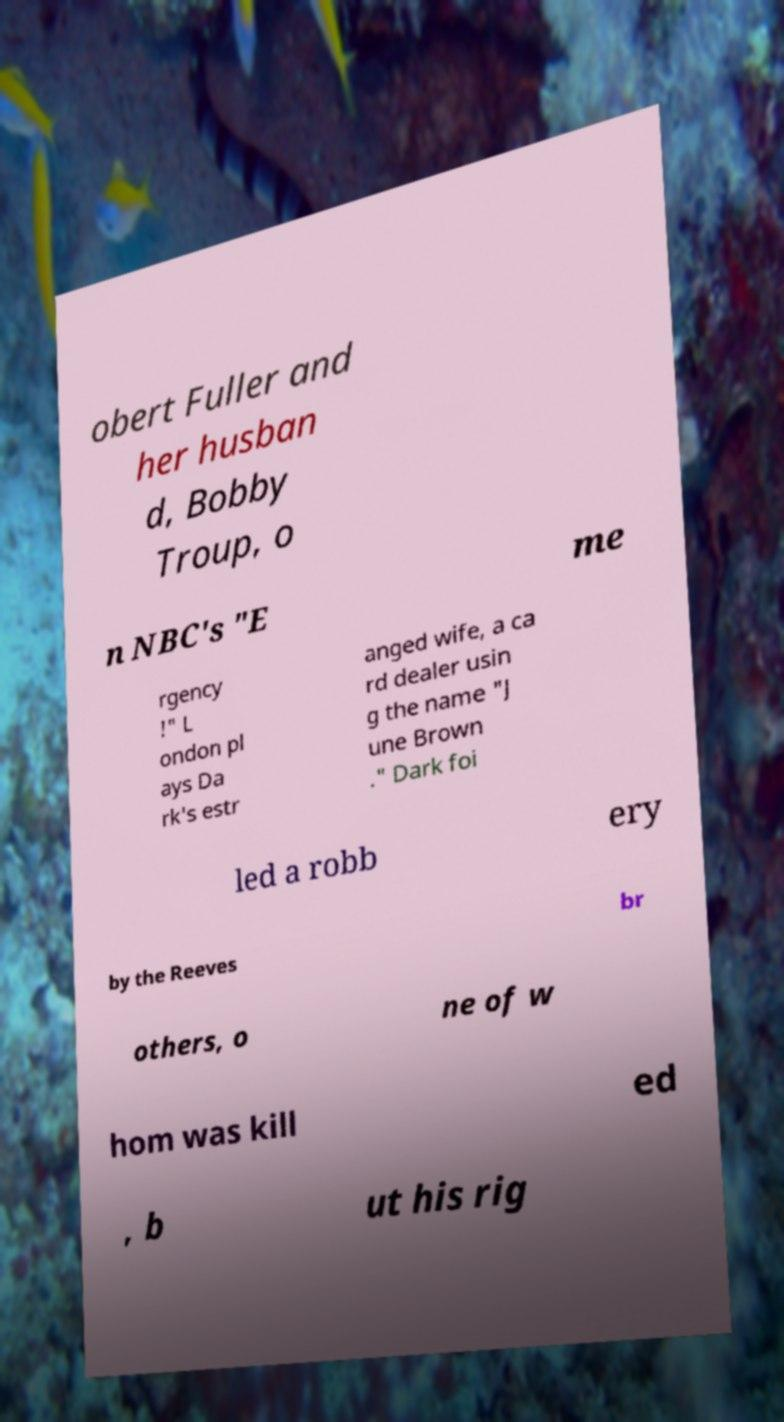Could you assist in decoding the text presented in this image and type it out clearly? obert Fuller and her husban d, Bobby Troup, o n NBC's "E me rgency !" L ondon pl ays Da rk's estr anged wife, a ca rd dealer usin g the name "J une Brown ." Dark foi led a robb ery by the Reeves br others, o ne of w hom was kill ed , b ut his rig 